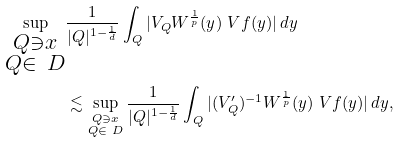Convert formula to latex. <formula><loc_0><loc_0><loc_500><loc_500>\sup _ { \substack { Q \ni x \\ Q \in \ D } } & \frac { 1 } { | Q | ^ { 1 - \frac { 1 } { d } } } \int _ { Q } | V _ { Q } W ^ { \frac { 1 } { p } } ( y ) \ V { f } ( y ) | \, d y \\ & \lesssim \sup _ { \substack { Q \ni x \\ Q \in \ D } } \frac { 1 } { | Q | ^ { 1 - \frac { 1 } { d } } } \int _ { Q } | ( V _ { Q } ^ { \prime } ) ^ { - 1 } W ^ { \frac { 1 } { p } } ( y ) \ V { f } ( y ) | \, d y ,</formula> 